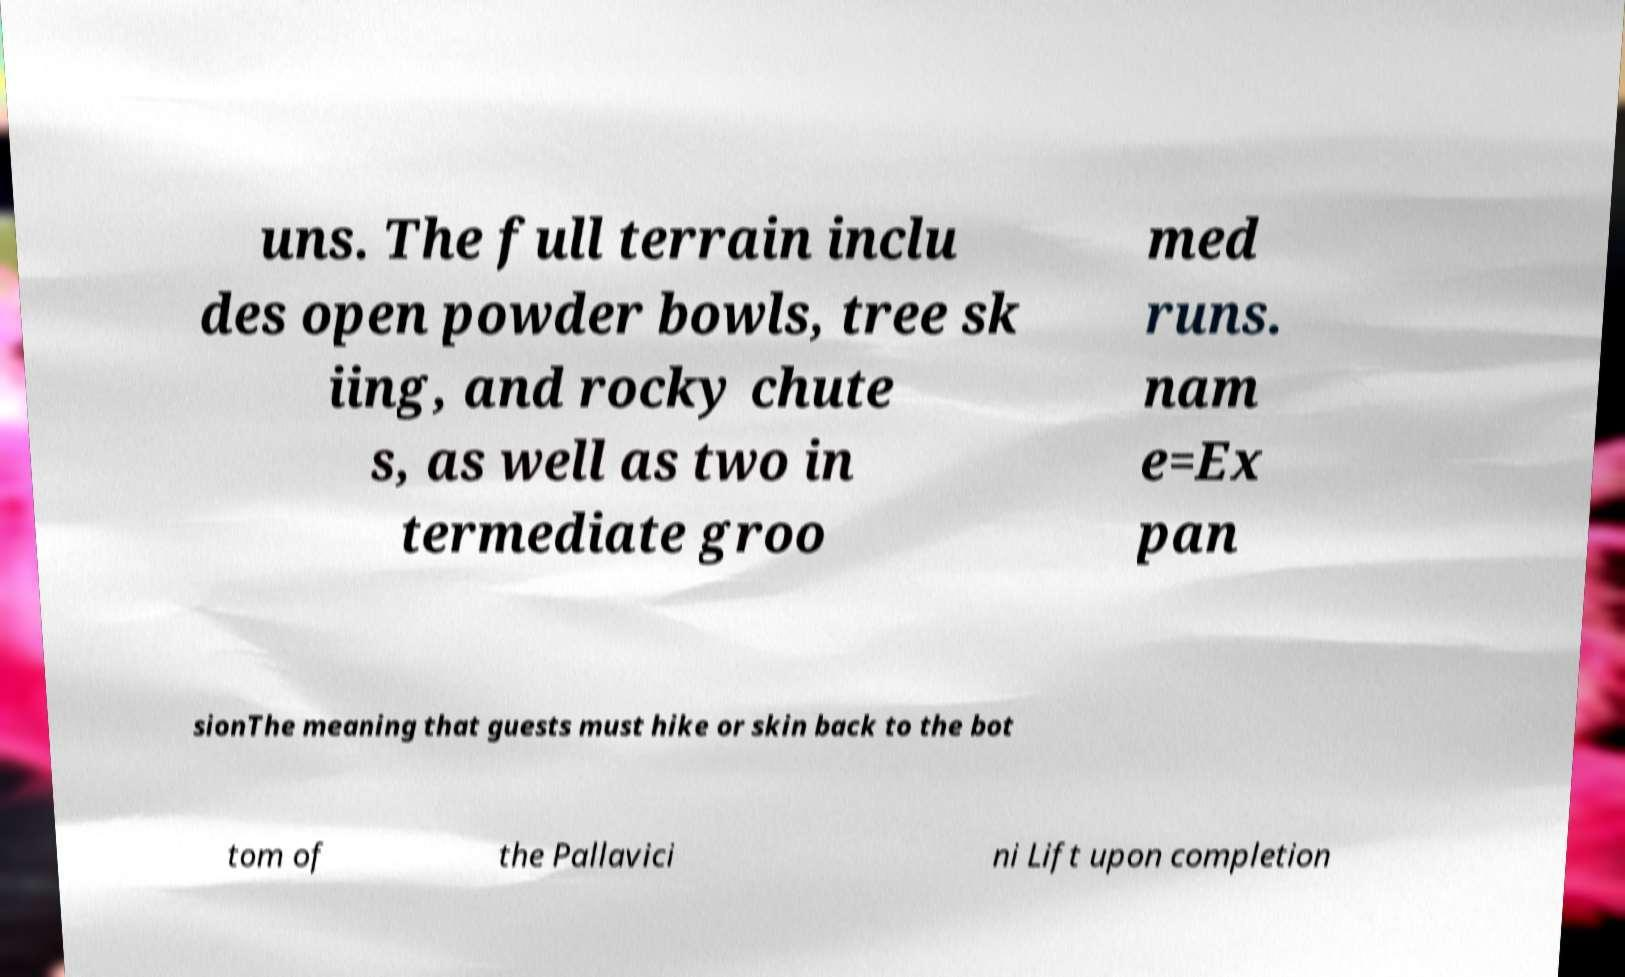Please identify and transcribe the text found in this image. uns. The full terrain inclu des open powder bowls, tree sk iing, and rocky chute s, as well as two in termediate groo med runs. nam e=Ex pan sionThe meaning that guests must hike or skin back to the bot tom of the Pallavici ni Lift upon completion 